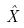<formula> <loc_0><loc_0><loc_500><loc_500>\hat { X }</formula> 